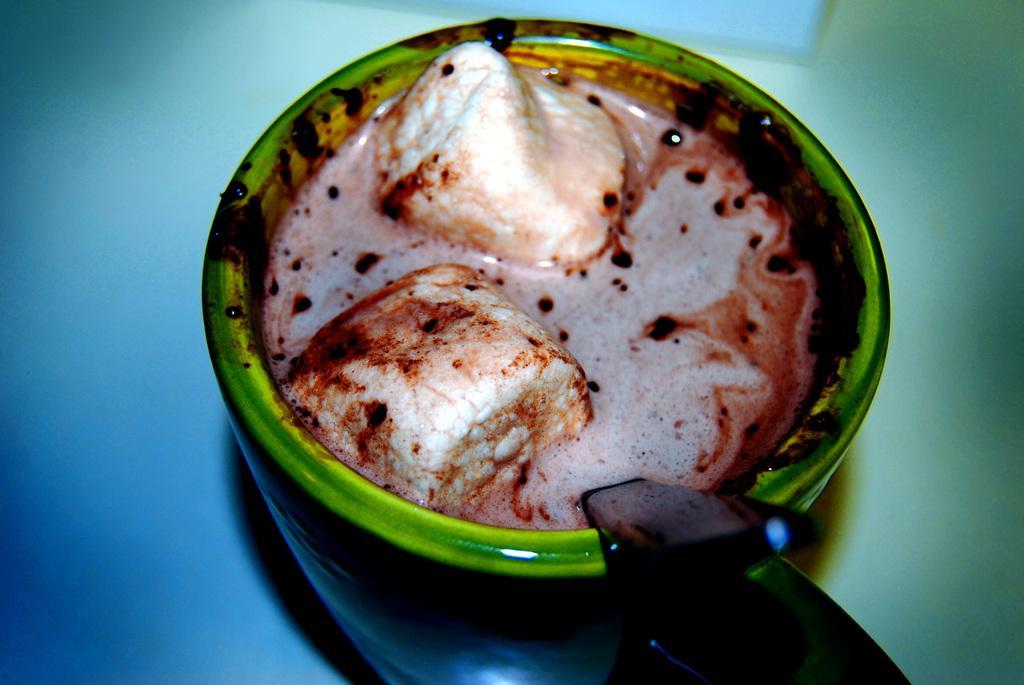Describe this image in one or two sentences. In this image I can see a food in the cup. Food is in white,cream and brown color. I can see a spoon and background is in blue color. 